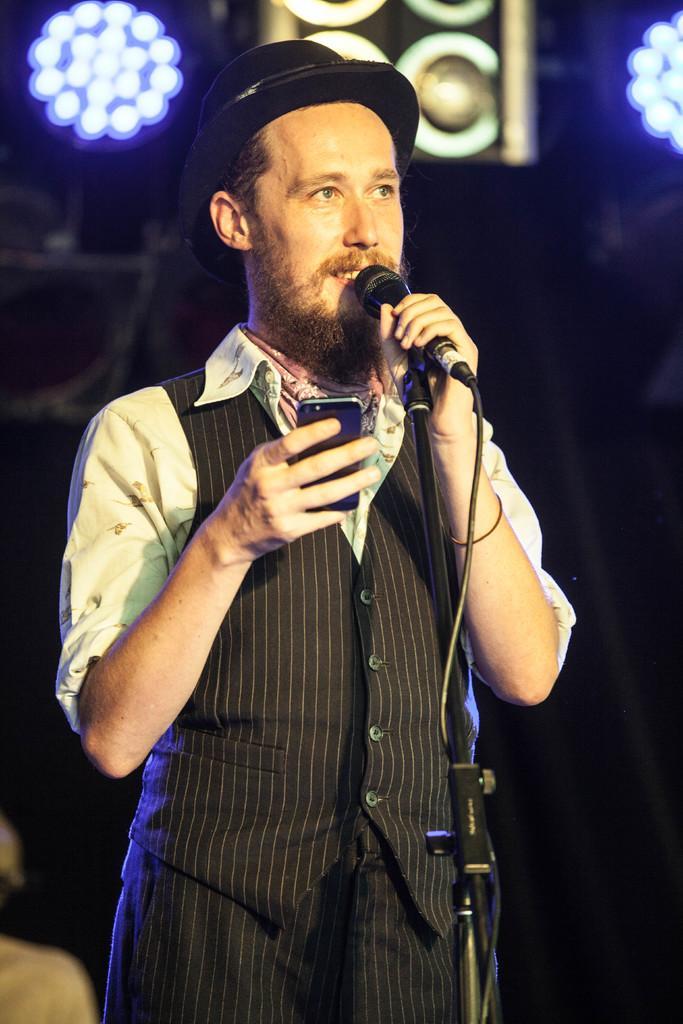In one or two sentences, can you explain what this image depicts? In this image, we can see a man is smiling and holding a mobile, microphone with stand and wire. He wore a hat. Background there is a blur view. Here we can see some lights, speaker. 